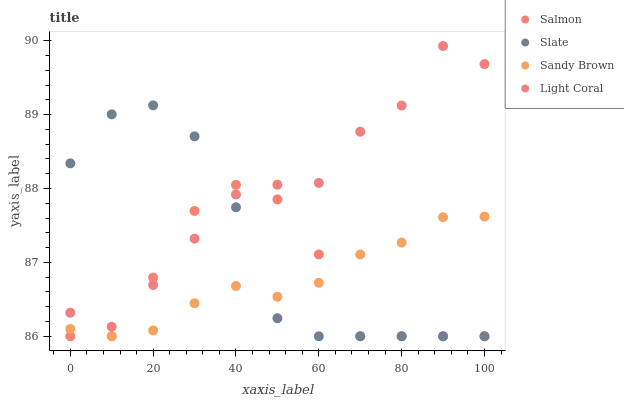Does Sandy Brown have the minimum area under the curve?
Answer yes or no. Yes. Does Light Coral have the maximum area under the curve?
Answer yes or no. Yes. Does Slate have the minimum area under the curve?
Answer yes or no. No. Does Slate have the maximum area under the curve?
Answer yes or no. No. Is Sandy Brown the smoothest?
Answer yes or no. Yes. Is Salmon the roughest?
Answer yes or no. Yes. Is Slate the smoothest?
Answer yes or no. No. Is Slate the roughest?
Answer yes or no. No. Does Sandy Brown have the lowest value?
Answer yes or no. Yes. Does Light Coral have the highest value?
Answer yes or no. Yes. Does Slate have the highest value?
Answer yes or no. No. Is Sandy Brown less than Light Coral?
Answer yes or no. Yes. Is Light Coral greater than Sandy Brown?
Answer yes or no. Yes. Does Sandy Brown intersect Slate?
Answer yes or no. Yes. Is Sandy Brown less than Slate?
Answer yes or no. No. Is Sandy Brown greater than Slate?
Answer yes or no. No. Does Sandy Brown intersect Light Coral?
Answer yes or no. No. 